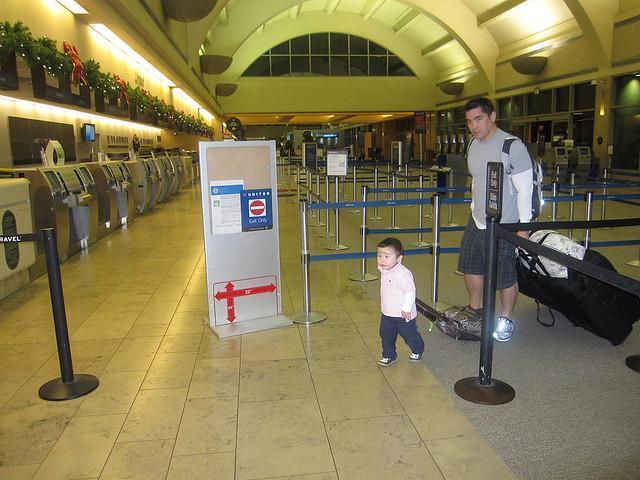How many people can you see?
Give a very brief answer. 2. How many signs have bus icon on a pole?
Give a very brief answer. 0. 